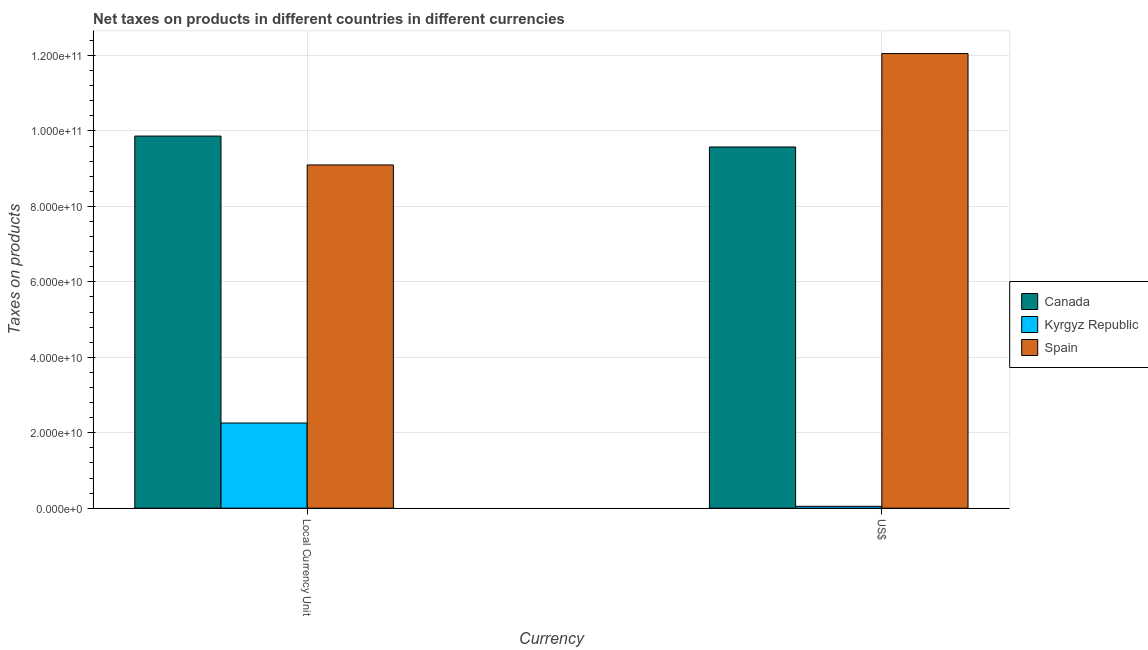How many different coloured bars are there?
Give a very brief answer. 3. How many bars are there on the 2nd tick from the left?
Your response must be concise. 3. How many bars are there on the 1st tick from the right?
Offer a very short reply. 3. What is the label of the 2nd group of bars from the left?
Offer a terse response. US$. What is the net taxes in constant 2005 us$ in Kyrgyz Republic?
Keep it short and to the point. 2.26e+1. Across all countries, what is the maximum net taxes in constant 2005 us$?
Your answer should be very brief. 9.87e+1. Across all countries, what is the minimum net taxes in us$?
Provide a succinct answer. 4.91e+08. In which country was the net taxes in constant 2005 us$ maximum?
Provide a short and direct response. Canada. In which country was the net taxes in us$ minimum?
Your answer should be very brief. Kyrgyz Republic. What is the total net taxes in constant 2005 us$ in the graph?
Offer a very short reply. 2.12e+11. What is the difference between the net taxes in us$ in Canada and that in Kyrgyz Republic?
Provide a succinct answer. 9.53e+1. What is the difference between the net taxes in us$ in Kyrgyz Republic and the net taxes in constant 2005 us$ in Spain?
Ensure brevity in your answer.  -9.05e+1. What is the average net taxes in constant 2005 us$ per country?
Keep it short and to the point. 7.07e+1. What is the difference between the net taxes in us$ and net taxes in constant 2005 us$ in Kyrgyz Republic?
Your response must be concise. -2.21e+1. What is the ratio of the net taxes in us$ in Kyrgyz Republic to that in Spain?
Provide a short and direct response. 0. Is the net taxes in us$ in Spain less than that in Kyrgyz Republic?
Provide a short and direct response. No. What does the 2nd bar from the right in Local Currency Unit represents?
Make the answer very short. Kyrgyz Republic. How many countries are there in the graph?
Provide a succinct answer. 3. Are the values on the major ticks of Y-axis written in scientific E-notation?
Your response must be concise. Yes. Does the graph contain grids?
Provide a short and direct response. Yes. Where does the legend appear in the graph?
Your answer should be compact. Center right. How are the legend labels stacked?
Provide a succinct answer. Vertical. What is the title of the graph?
Your answer should be compact. Net taxes on products in different countries in different currencies. What is the label or title of the X-axis?
Make the answer very short. Currency. What is the label or title of the Y-axis?
Keep it short and to the point. Taxes on products. What is the Taxes on products of Canada in Local Currency Unit?
Your answer should be very brief. 9.87e+1. What is the Taxes on products of Kyrgyz Republic in Local Currency Unit?
Your answer should be compact. 2.26e+1. What is the Taxes on products in Spain in Local Currency Unit?
Make the answer very short. 9.10e+1. What is the Taxes on products of Canada in US$?
Your answer should be very brief. 9.58e+1. What is the Taxes on products of Kyrgyz Republic in US$?
Your answer should be very brief. 4.91e+08. What is the Taxes on products in Spain in US$?
Your answer should be compact. 1.21e+11. Across all Currency, what is the maximum Taxes on products of Canada?
Make the answer very short. 9.87e+1. Across all Currency, what is the maximum Taxes on products of Kyrgyz Republic?
Your answer should be very brief. 2.26e+1. Across all Currency, what is the maximum Taxes on products of Spain?
Offer a terse response. 1.21e+11. Across all Currency, what is the minimum Taxes on products of Canada?
Make the answer very short. 9.58e+1. Across all Currency, what is the minimum Taxes on products of Kyrgyz Republic?
Offer a terse response. 4.91e+08. Across all Currency, what is the minimum Taxes on products of Spain?
Offer a very short reply. 9.10e+1. What is the total Taxes on products of Canada in the graph?
Give a very brief answer. 1.94e+11. What is the total Taxes on products in Kyrgyz Republic in the graph?
Provide a succinct answer. 2.31e+1. What is the total Taxes on products in Spain in the graph?
Ensure brevity in your answer.  2.12e+11. What is the difference between the Taxes on products in Canada in Local Currency Unit and that in US$?
Offer a terse response. 2.89e+09. What is the difference between the Taxes on products in Kyrgyz Republic in Local Currency Unit and that in US$?
Your response must be concise. 2.21e+1. What is the difference between the Taxes on products in Spain in Local Currency Unit and that in US$?
Give a very brief answer. -2.95e+1. What is the difference between the Taxes on products in Canada in Local Currency Unit and the Taxes on products in Kyrgyz Republic in US$?
Your answer should be very brief. 9.82e+1. What is the difference between the Taxes on products in Canada in Local Currency Unit and the Taxes on products in Spain in US$?
Offer a very short reply. -2.19e+1. What is the difference between the Taxes on products of Kyrgyz Republic in Local Currency Unit and the Taxes on products of Spain in US$?
Offer a terse response. -9.79e+1. What is the average Taxes on products in Canada per Currency?
Give a very brief answer. 9.72e+1. What is the average Taxes on products in Kyrgyz Republic per Currency?
Your response must be concise. 1.15e+1. What is the average Taxes on products in Spain per Currency?
Keep it short and to the point. 1.06e+11. What is the difference between the Taxes on products of Canada and Taxes on products of Kyrgyz Republic in Local Currency Unit?
Your answer should be compact. 7.61e+1. What is the difference between the Taxes on products in Canada and Taxes on products in Spain in Local Currency Unit?
Offer a very short reply. 7.65e+09. What is the difference between the Taxes on products in Kyrgyz Republic and Taxes on products in Spain in Local Currency Unit?
Keep it short and to the point. -6.84e+1. What is the difference between the Taxes on products in Canada and Taxes on products in Kyrgyz Republic in US$?
Your answer should be very brief. 9.53e+1. What is the difference between the Taxes on products of Canada and Taxes on products of Spain in US$?
Your response must be concise. -2.48e+1. What is the difference between the Taxes on products of Kyrgyz Republic and Taxes on products of Spain in US$?
Offer a very short reply. -1.20e+11. What is the ratio of the Taxes on products in Canada in Local Currency Unit to that in US$?
Ensure brevity in your answer.  1.03. What is the ratio of the Taxes on products in Kyrgyz Republic in Local Currency Unit to that in US$?
Your answer should be compact. 45.96. What is the ratio of the Taxes on products of Spain in Local Currency Unit to that in US$?
Offer a very short reply. 0.76. What is the difference between the highest and the second highest Taxes on products of Canada?
Ensure brevity in your answer.  2.89e+09. What is the difference between the highest and the second highest Taxes on products of Kyrgyz Republic?
Offer a terse response. 2.21e+1. What is the difference between the highest and the second highest Taxes on products of Spain?
Keep it short and to the point. 2.95e+1. What is the difference between the highest and the lowest Taxes on products in Canada?
Keep it short and to the point. 2.89e+09. What is the difference between the highest and the lowest Taxes on products in Kyrgyz Republic?
Offer a very short reply. 2.21e+1. What is the difference between the highest and the lowest Taxes on products in Spain?
Provide a succinct answer. 2.95e+1. 